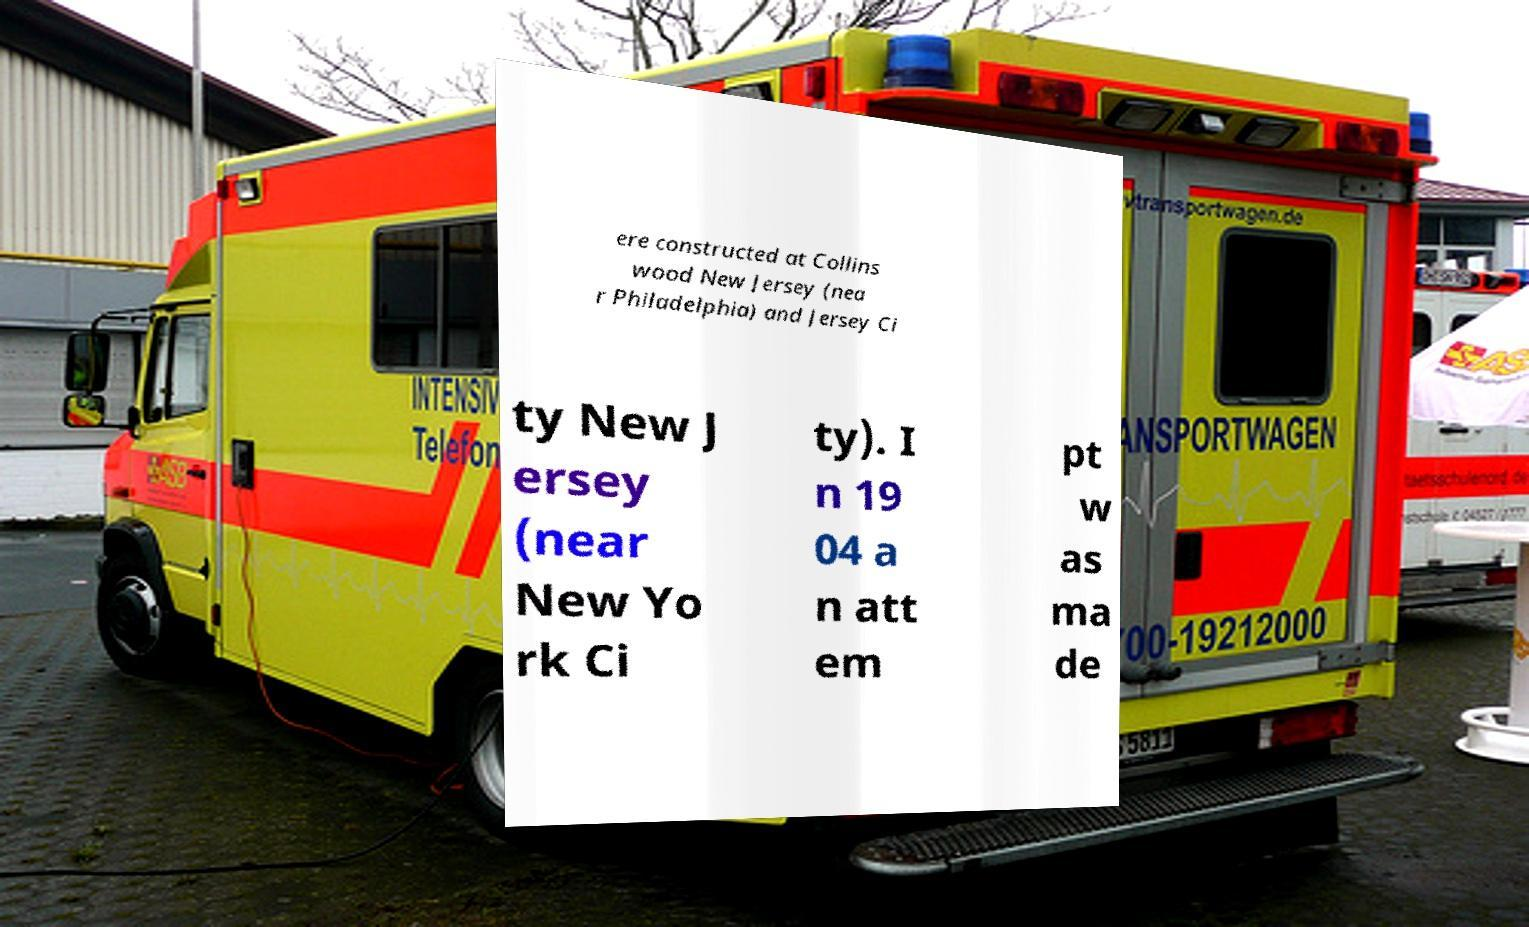I need the written content from this picture converted into text. Can you do that? ere constructed at Collins wood New Jersey (nea r Philadelphia) and Jersey Ci ty New J ersey (near New Yo rk Ci ty). I n 19 04 a n att em pt w as ma de 